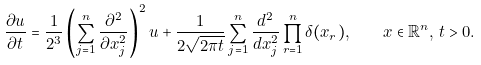<formula> <loc_0><loc_0><loc_500><loc_500>\frac { \partial u } { \partial t } = \frac { 1 } { 2 ^ { 3 } } \left ( \sum _ { j = 1 } ^ { n } \frac { \partial ^ { 2 } } { \partial x ^ { 2 } _ { j } } \right ) ^ { 2 } u + \frac { 1 } { 2 \sqrt { 2 \pi t } } \sum _ { j = 1 } ^ { n } \frac { d ^ { 2 } } { d x ^ { 2 } _ { j } } \prod _ { r = 1 } ^ { n } \delta ( x _ { r } ) , \quad x \in \mathbb { R } ^ { n } , \, t > 0 .</formula> 